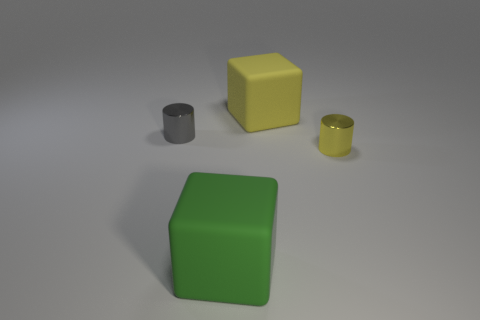There is a thing that is both to the left of the big yellow cube and on the right side of the gray thing; what material is it?
Offer a very short reply. Rubber. There is a green matte object; what number of tiny gray metal cylinders are left of it?
Ensure brevity in your answer.  1. There is a cube that is made of the same material as the big yellow object; what color is it?
Offer a terse response. Green. Is the shape of the small yellow metallic object the same as the gray shiny thing?
Ensure brevity in your answer.  Yes. How many things are behind the tiny yellow metal cylinder and to the right of the tiny gray shiny cylinder?
Offer a terse response. 1. What number of metallic objects are either big brown objects or small objects?
Provide a succinct answer. 2. There is a block that is right of the big thing that is in front of the small gray metallic cylinder; what size is it?
Offer a terse response. Large. Is there a green thing that is in front of the small thing that is behind the shiny cylinder that is in front of the gray cylinder?
Offer a very short reply. Yes. Is the thing in front of the small yellow metallic cylinder made of the same material as the cylinder that is on the right side of the yellow block?
Provide a short and direct response. No. How many things are either cyan blocks or objects behind the green cube?
Offer a very short reply. 3. 